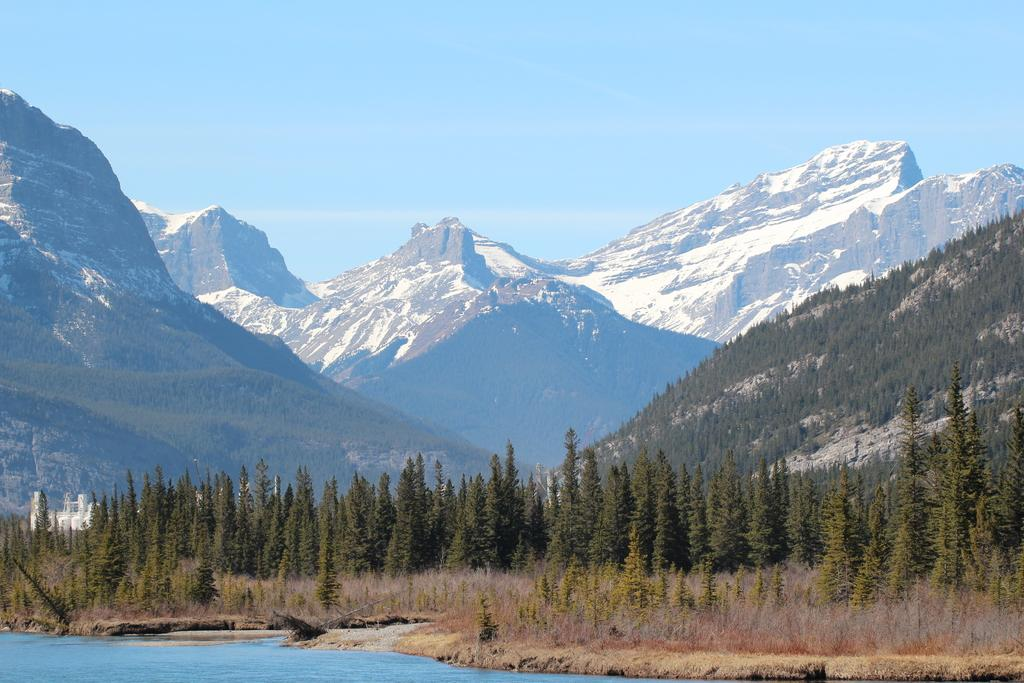What type of vegetation can be seen in the image? There is a group of trees and plants visible in the image. What natural element is present in the image? There is water visible in the image. What type of man-made structures are in the image? There are buildings in the image. What unique geographical feature can be seen in the image? There are ice hills in the image. What is visible in the background of the image? The sky is visible in the image. What type of bell can be seen hanging from the trees in the image? There is no bell present in the image; it features a group of trees, plants, water, buildings, ice hills, and the sky. 